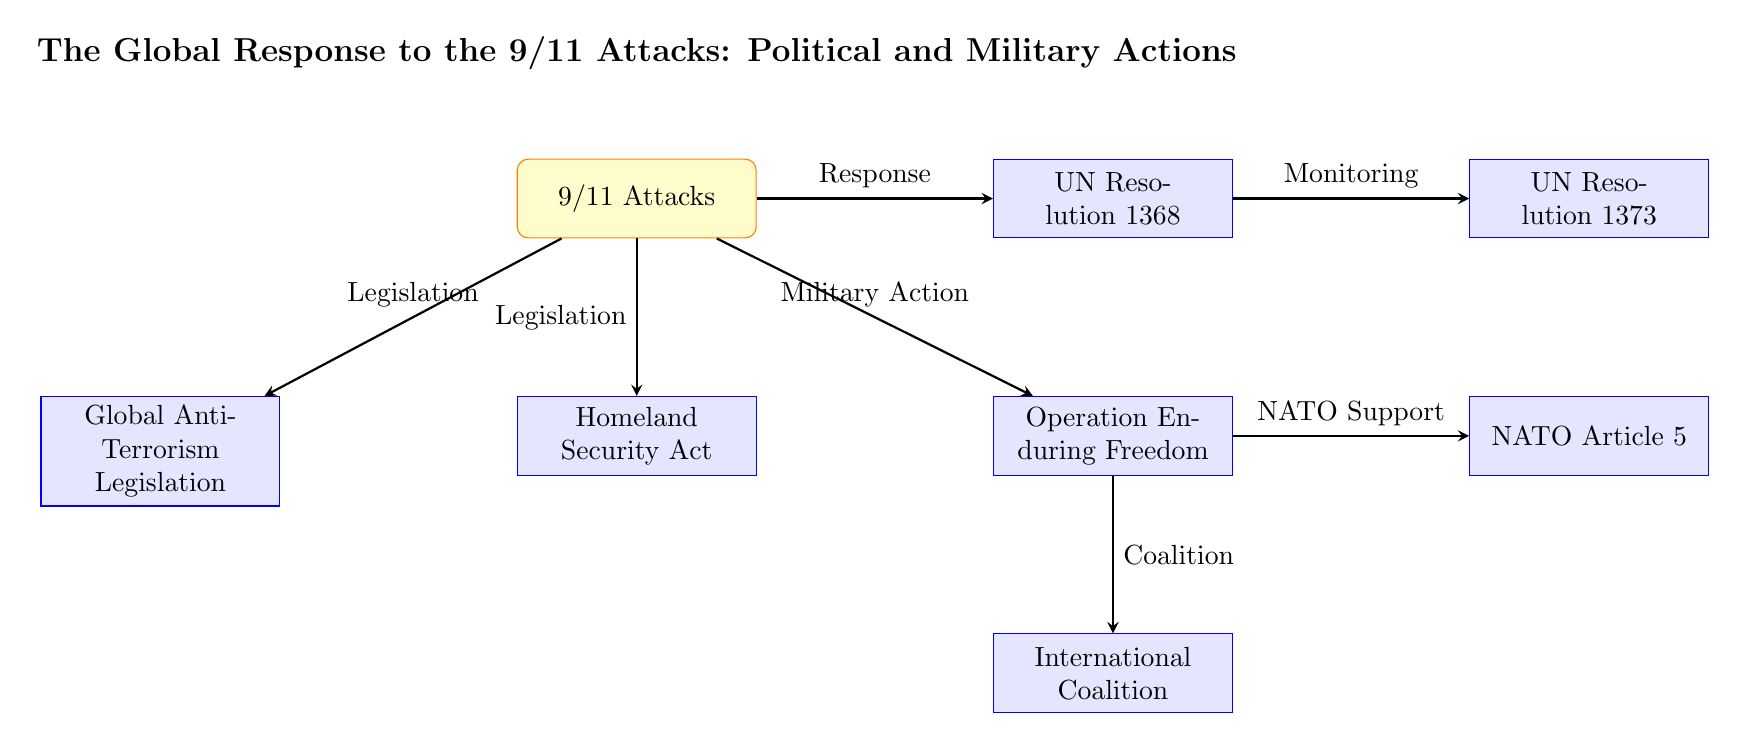What is the main event represented at the top of the diagram? The main event at the top of the diagram is the "9/11 Attacks," which is central to the responses that follow.
Answer: 9/11 Attacks How many actions are directly related to the "9/11 Attacks"? There are four actions directly related to the "9/11 Attacks": the UN Resolution 1368, Operation Enduring Freedom, the Homeland Security Act, and Global Anti-Terrorism Legislation. Counting these allows you to see the immediate political and military actions taken in response.
Answer: 4 What does Operation Enduring Freedom represent? Operation Enduring Freedom is depicted as a U.S.-led military campaign in Afghanistan, specifically designed to dismantle al-Qaeda and remove the Taliban from power, reflecting a significant military action following the attacks.
Answer: U.S.-led military campaign Which node follows immediately after Operation Enduring Freedom in the diagram? After Operation Enduring Freedom, the next node is the "International Coalition," indicating that this represents a cooperative effort among countries involved in the military response.
Answer: International Coalition What is the purpose of the UN Security Council Resolution 1373 as shown in the flowchart? The purpose of the UN Security Council Resolution 1373 is to establish a Counter-Terrorism Committee to monitor international cooperation, following the condemnation and response to the attacks represented by Resolution 1368. This illustrates the ongoing international efforts against terrorism.
Answer: Monitoring Which action did NATO take in response to the 9/11 attacks? NATO invoked Article 5 in response to the 9/11 attacks, which is shown as an action connected to the military operation, emphasizing collective defense. This was a landmark moment for NATO's alliance structure.
Answer: NATO Article 5 What is the relationship between the "UN Resolution 1368" and "UN Resolution 1373"? The relationship is that UN Resolution 1368 leads to UN Resolution 1373, where the former addresses the immediate response and the latter establishes a method for international monitoring and cooperation against terrorism. This indicates a continuing effort following an initial declaration.
Answer: Monitoring How does the diagram categorize the legislative response to the 9/11 attacks? The legislative response to the attacks is categorized under both the "Homeland Security Act" and "Global Anti-Terrorism Legislation," both stemming from the 9/11 Attacks node, representing different facets of legislation aimed at enhancing national security.
Answer: Legislation 